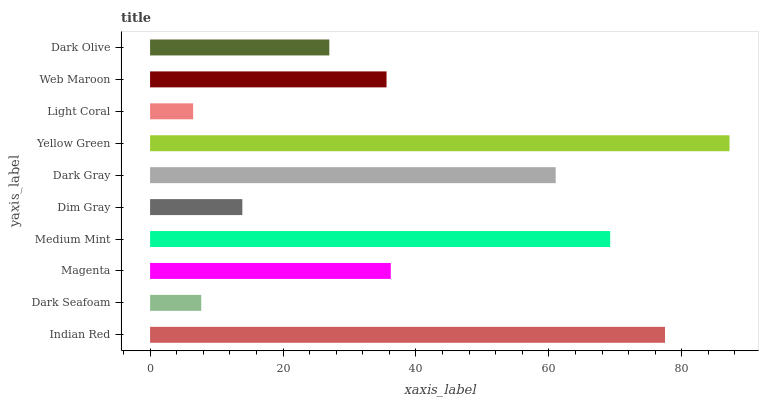Is Light Coral the minimum?
Answer yes or no. Yes. Is Yellow Green the maximum?
Answer yes or no. Yes. Is Dark Seafoam the minimum?
Answer yes or no. No. Is Dark Seafoam the maximum?
Answer yes or no. No. Is Indian Red greater than Dark Seafoam?
Answer yes or no. Yes. Is Dark Seafoam less than Indian Red?
Answer yes or no. Yes. Is Dark Seafoam greater than Indian Red?
Answer yes or no. No. Is Indian Red less than Dark Seafoam?
Answer yes or no. No. Is Magenta the high median?
Answer yes or no. Yes. Is Web Maroon the low median?
Answer yes or no. Yes. Is Dark Seafoam the high median?
Answer yes or no. No. Is Indian Red the low median?
Answer yes or no. No. 